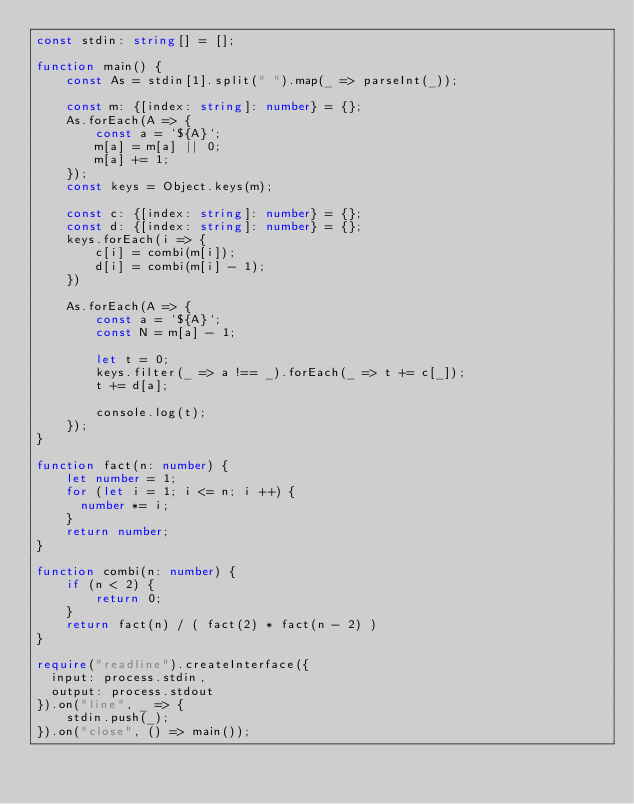<code> <loc_0><loc_0><loc_500><loc_500><_TypeScript_>const stdin: string[] = [];

function main() {
    const As = stdin[1].split(" ").map(_ => parseInt(_));

    const m: {[index: string]: number} = {};
    As.forEach(A => {
        const a = `${A}`;
        m[a] = m[a] || 0;
        m[a] += 1;
    });
    const keys = Object.keys(m);
    
    const c: {[index: string]: number} = {};
    const d: {[index: string]: number} = {};
    keys.forEach(i => {
        c[i] = combi(m[i]);
        d[i] = combi(m[i] - 1);
    })
    
    As.forEach(A => {
        const a = `${A}`;
        const N = m[a] - 1;

        let t = 0;
        keys.filter(_ => a !== _).forEach(_ => t += c[_]);
        t += d[a];

        console.log(t);
    });
}

function fact(n: number) {
    let number = 1;
    for (let i = 1; i <= n; i ++) {
      number *= i;
    }
    return number;
}

function combi(n: number) {
    if (n < 2) {
        return 0;
    }
    return fact(n) / ( fact(2) * fact(n - 2) )
}

require("readline").createInterface({
  input: process.stdin,
  output: process.stdout
}).on("line", _ => {
    stdin.push(_);
}).on("close", () => main());

</code> 